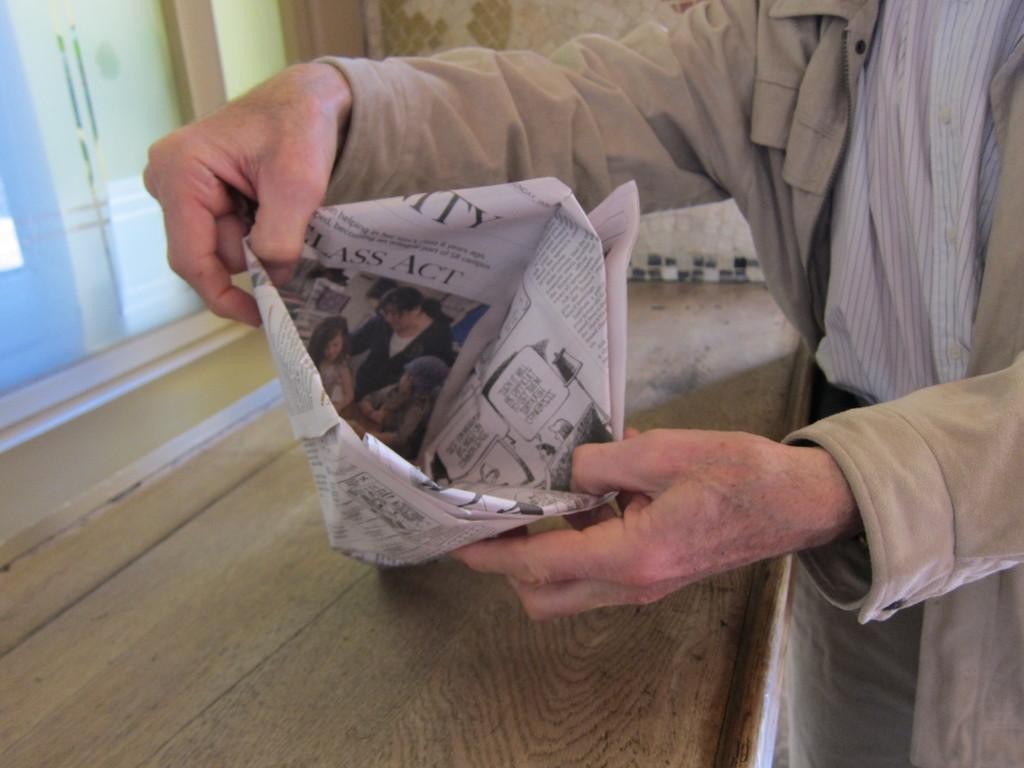What is being held by the hands in the image? There are hands holding a paper craft in the image. What type of material can be seen in the image? Wood is visible in the image. What is the background of the image made of? There is a wall in the image. What is on the left side of the image? There is glass on the left side of the image. What is the queen doing with the hammer in the image? There is no queen or hammer present in the image. 